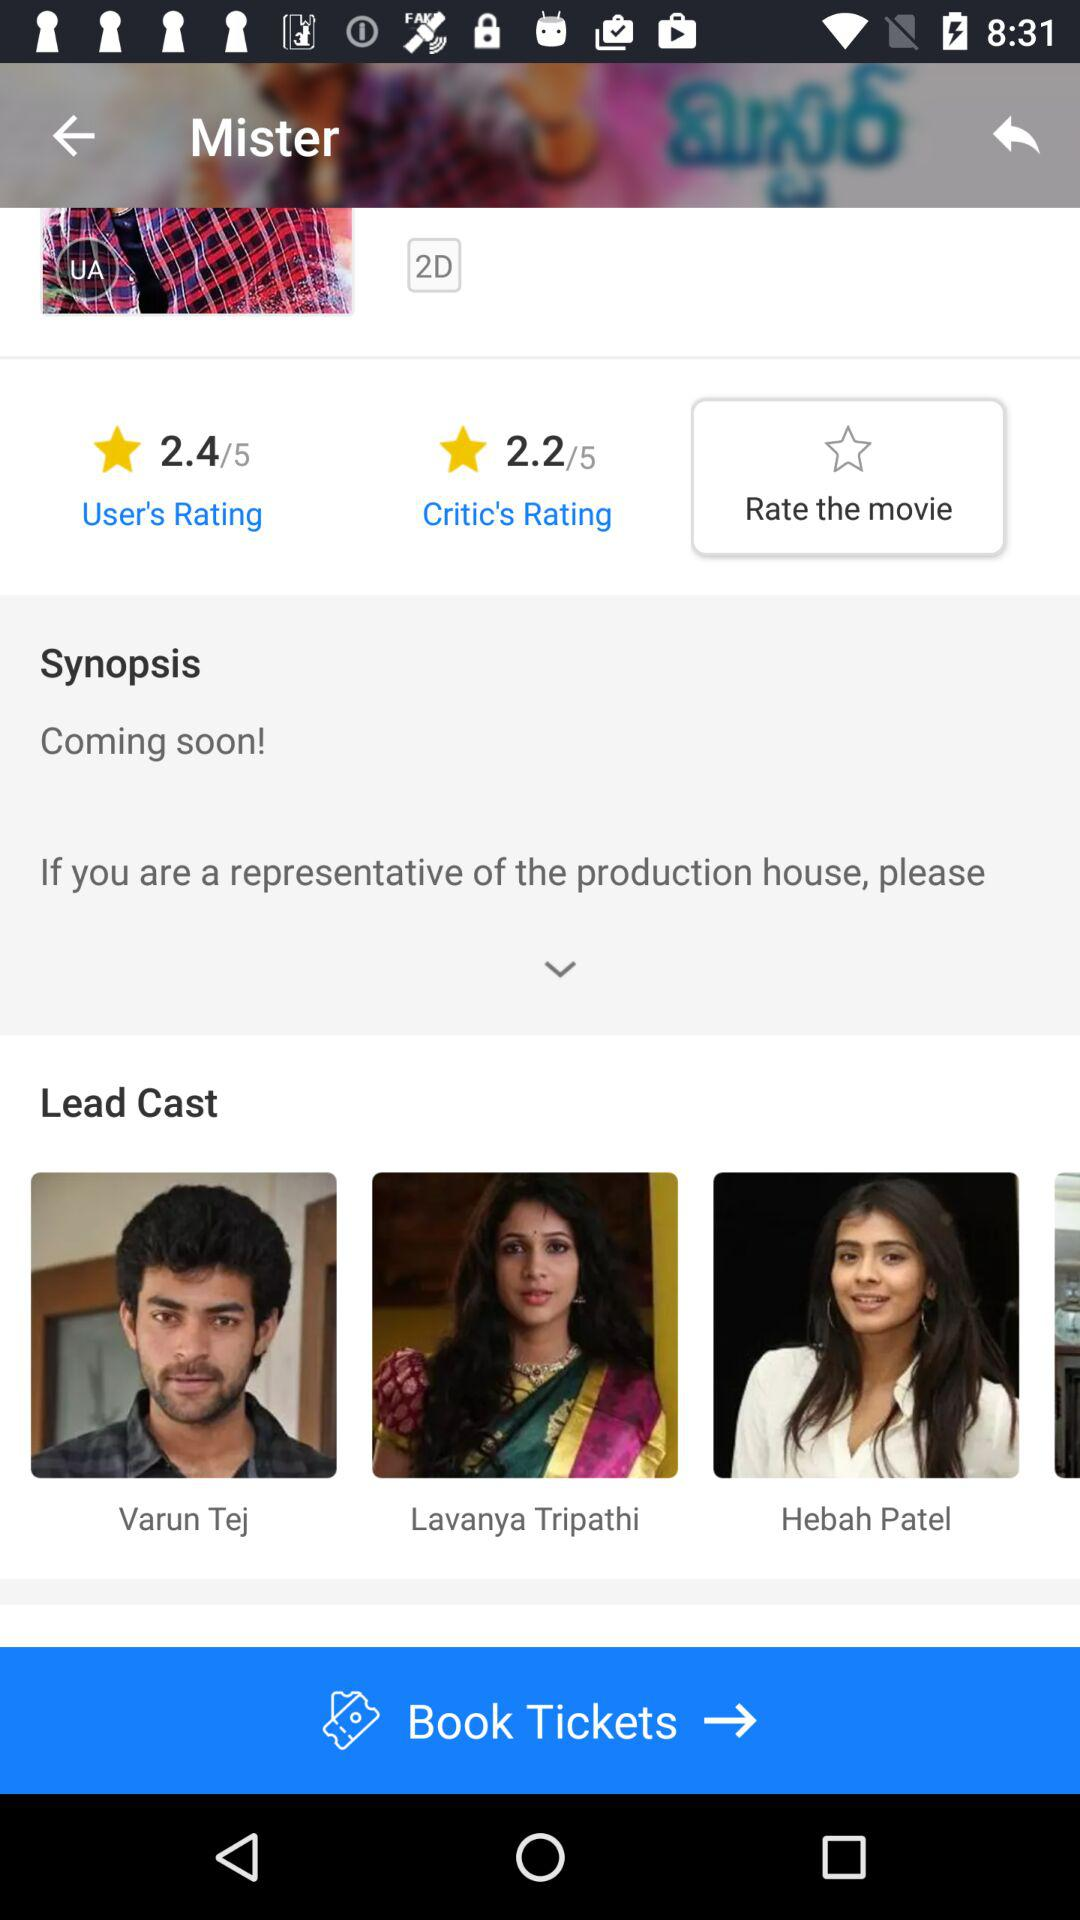What is the rating given by the users? The rating given by the users is 2.4. 